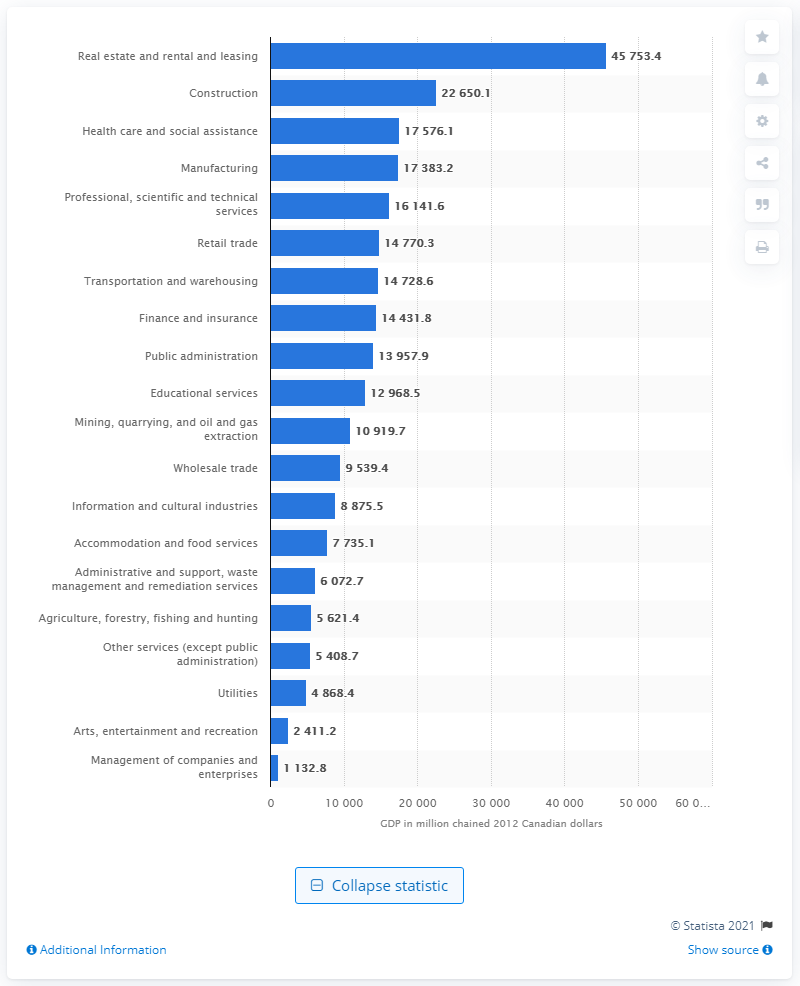List a handful of essential elements in this visual. In 2012, the GDP of the construction industry in British Columbia was 22,650.1 Canadian dollars. 